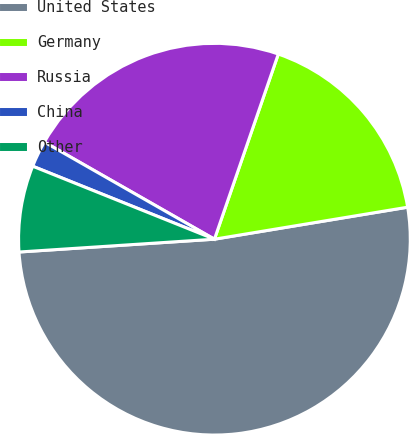Convert chart. <chart><loc_0><loc_0><loc_500><loc_500><pie_chart><fcel>United States<fcel>Germany<fcel>Russia<fcel>China<fcel>Other<nl><fcel>51.57%<fcel>17.1%<fcel>22.03%<fcel>2.18%<fcel>7.12%<nl></chart> 